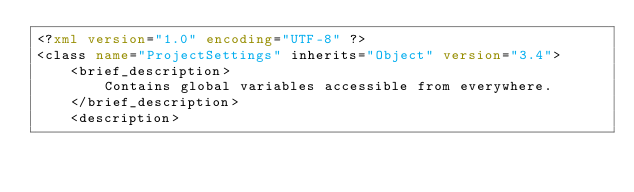<code> <loc_0><loc_0><loc_500><loc_500><_XML_><?xml version="1.0" encoding="UTF-8" ?>
<class name="ProjectSettings" inherits="Object" version="3.4">
	<brief_description>
		Contains global variables accessible from everywhere.
	</brief_description>
	<description></code> 